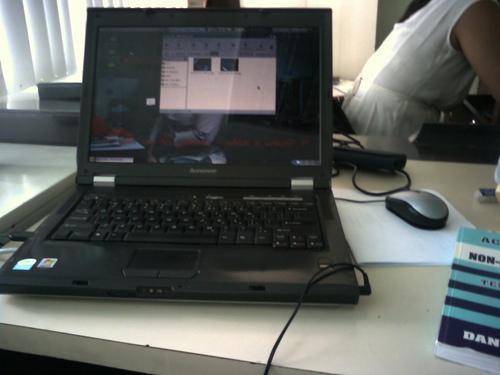How many oranges have stickers on them?
Give a very brief answer. 0. 